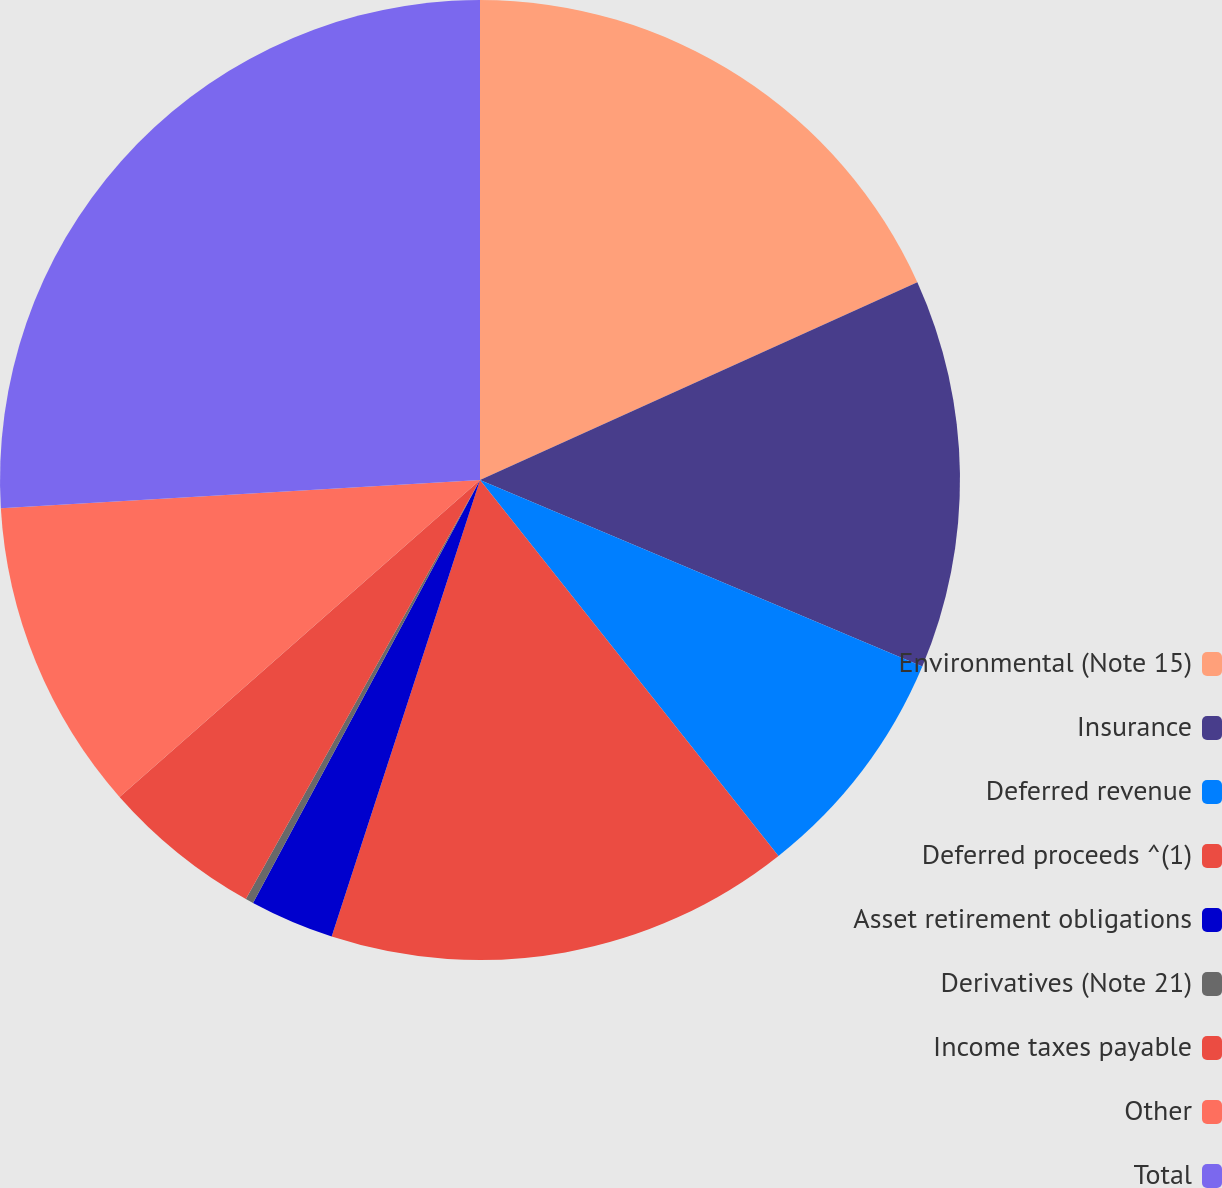Convert chart to OTSL. <chart><loc_0><loc_0><loc_500><loc_500><pie_chart><fcel>Environmental (Note 15)<fcel>Insurance<fcel>Deferred revenue<fcel>Deferred proceeds ^(1)<fcel>Asset retirement obligations<fcel>Derivatives (Note 21)<fcel>Income taxes payable<fcel>Other<fcel>Total<nl><fcel>18.24%<fcel>13.11%<fcel>7.97%<fcel>15.68%<fcel>2.84%<fcel>0.27%<fcel>5.41%<fcel>10.54%<fcel>25.94%<nl></chart> 